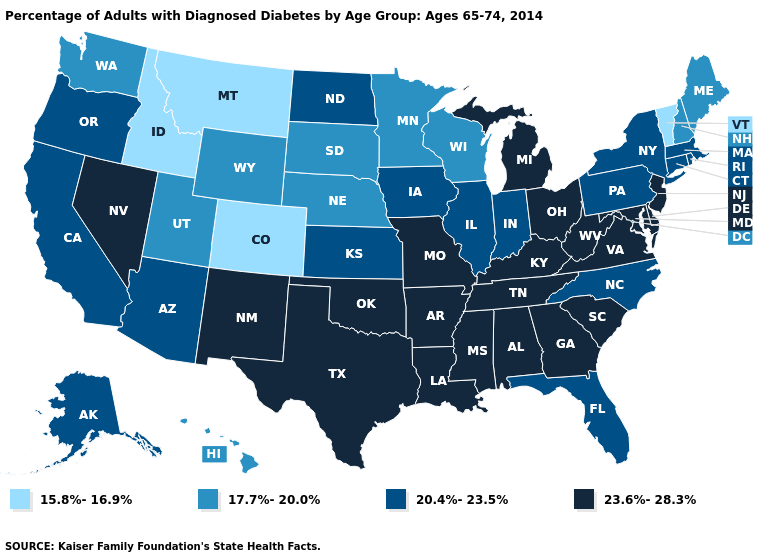Among the states that border New York , which have the highest value?
Concise answer only. New Jersey. Does New Jersey have the lowest value in the Northeast?
Quick response, please. No. Which states have the lowest value in the West?
Give a very brief answer. Colorado, Idaho, Montana. Name the states that have a value in the range 17.7%-20.0%?
Keep it brief. Hawaii, Maine, Minnesota, Nebraska, New Hampshire, South Dakota, Utah, Washington, Wisconsin, Wyoming. What is the lowest value in states that border Oregon?
Be succinct. 15.8%-16.9%. What is the value of Vermont?
Write a very short answer. 15.8%-16.9%. What is the value of Massachusetts?
Write a very short answer. 20.4%-23.5%. Does North Carolina have a higher value than Colorado?
Be succinct. Yes. Which states have the lowest value in the MidWest?
Be succinct. Minnesota, Nebraska, South Dakota, Wisconsin. Does the map have missing data?
Be succinct. No. Among the states that border Georgia , does North Carolina have the lowest value?
Keep it brief. Yes. Name the states that have a value in the range 17.7%-20.0%?
Short answer required. Hawaii, Maine, Minnesota, Nebraska, New Hampshire, South Dakota, Utah, Washington, Wisconsin, Wyoming. What is the highest value in states that border Pennsylvania?
Keep it brief. 23.6%-28.3%. What is the value of Louisiana?
Short answer required. 23.6%-28.3%. What is the value of Idaho?
Keep it brief. 15.8%-16.9%. 